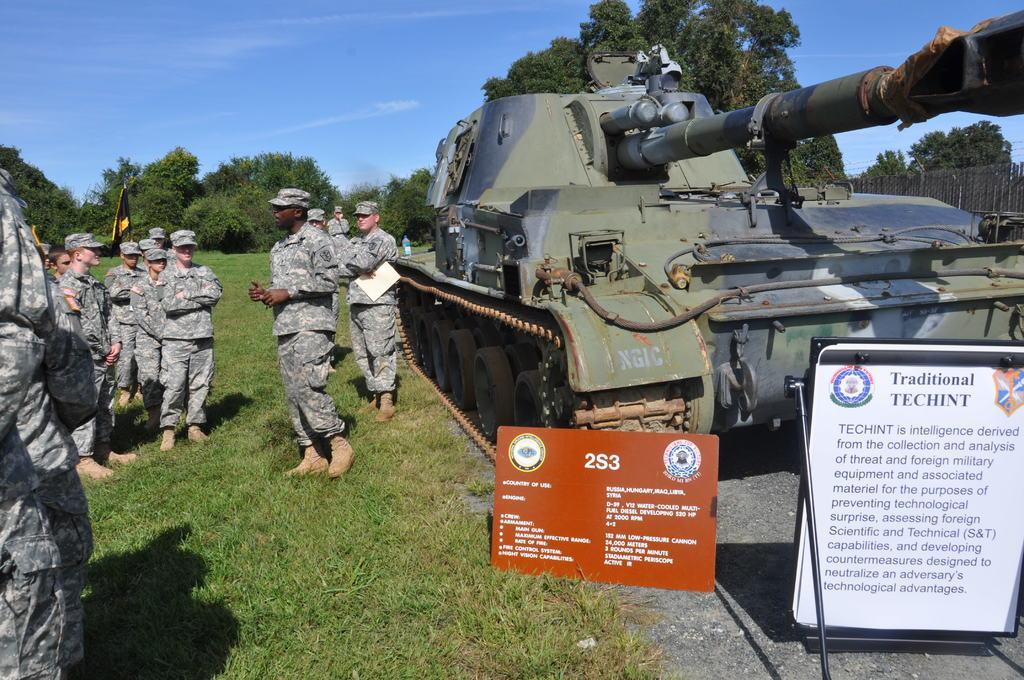Describe this image in one or two sentences. In the image we can see there are people standing on the ground and they are wearing caps. There is a war tank kept on the ground and there are stones on the ground. There are banners kept on the ground and behind there are lot of trees. There is a clear sky. 